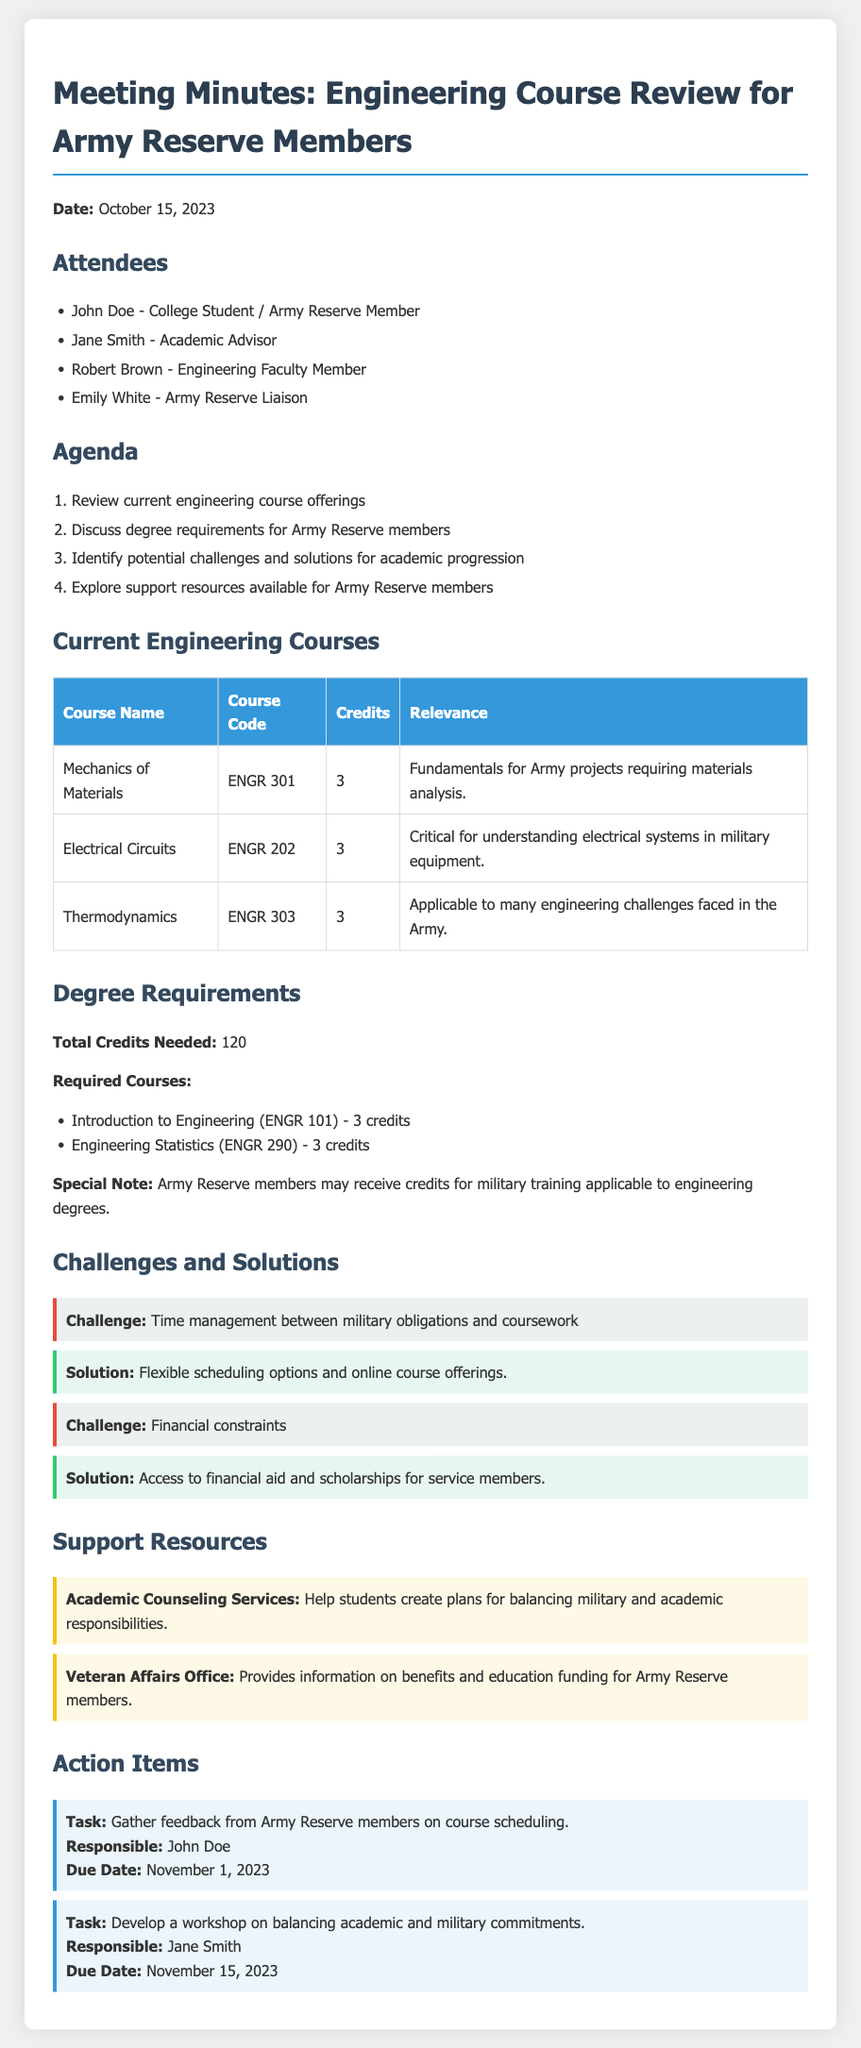what is the date of the meeting? The meeting was held on October 15, 2023, which is mentioned at the beginning of the document.
Answer: October 15, 2023 who is the academic advisor present at the meeting? Jane Smith is listed as the academic advisor among the attendees of the meeting.
Answer: Jane Smith how many credits are needed for the engineering degree? The document states that a total of 120 credits are required to complete the degree.
Answer: 120 what challenge is related to time management? The challenge of managing time between military obligations and coursework is specifically mentioned under challenges.
Answer: Time management between military obligations and coursework what is one of the solutions provided for financial constraints? The solution mentioned for financial constraints is access to financial aid and scholarships for service members.
Answer: Access to financial aid and scholarships who is responsible for gathering feedback from Army Reserve members? The document specifies that John Doe is responsible for this action item.
Answer: John Doe how many required courses are listed for the engineering degree? There are two required courses listed for the engineering degree in the document.
Answer: 2 what is one support resource available for Army Reserve members? The document lists academic counseling services as a support resource available for members.
Answer: Academic Counseling Services what is the due date for developing a workshop on academic and military commitments? The due date for this action item is November 15, 2023, as noted in the action items section.
Answer: November 15, 2023 